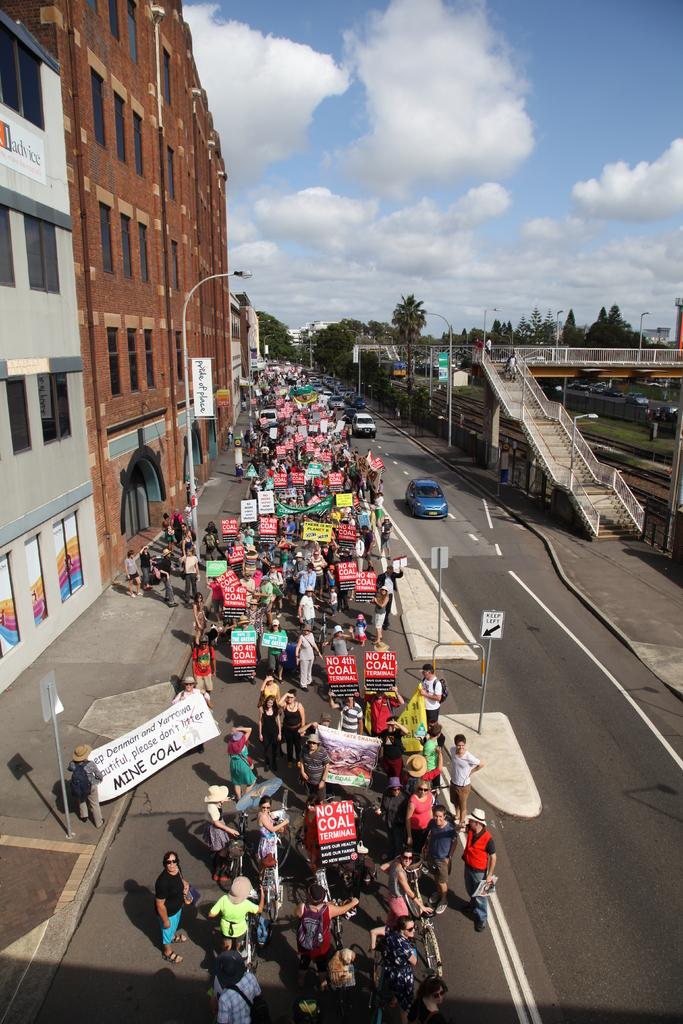What can be seen on the road in the image? There are vehicles and people on the road in the image. What is located on the left side of the image? There are buildings on the left side of the image. What type of vegetation and ground cover can be seen on the right side of the image? There are trees and grass on the right side of the image. What color is the sky in the image? The sky is blue in the image. What type of advertisement can be seen on the underwear of the people in the image? There is no advertisement on the underwear of the people in the image, as they are not wearing any underwear. What type of party is taking place on the road in the image? There is no party taking place on the road in the image; it is a regular scene with vehicles and people. 